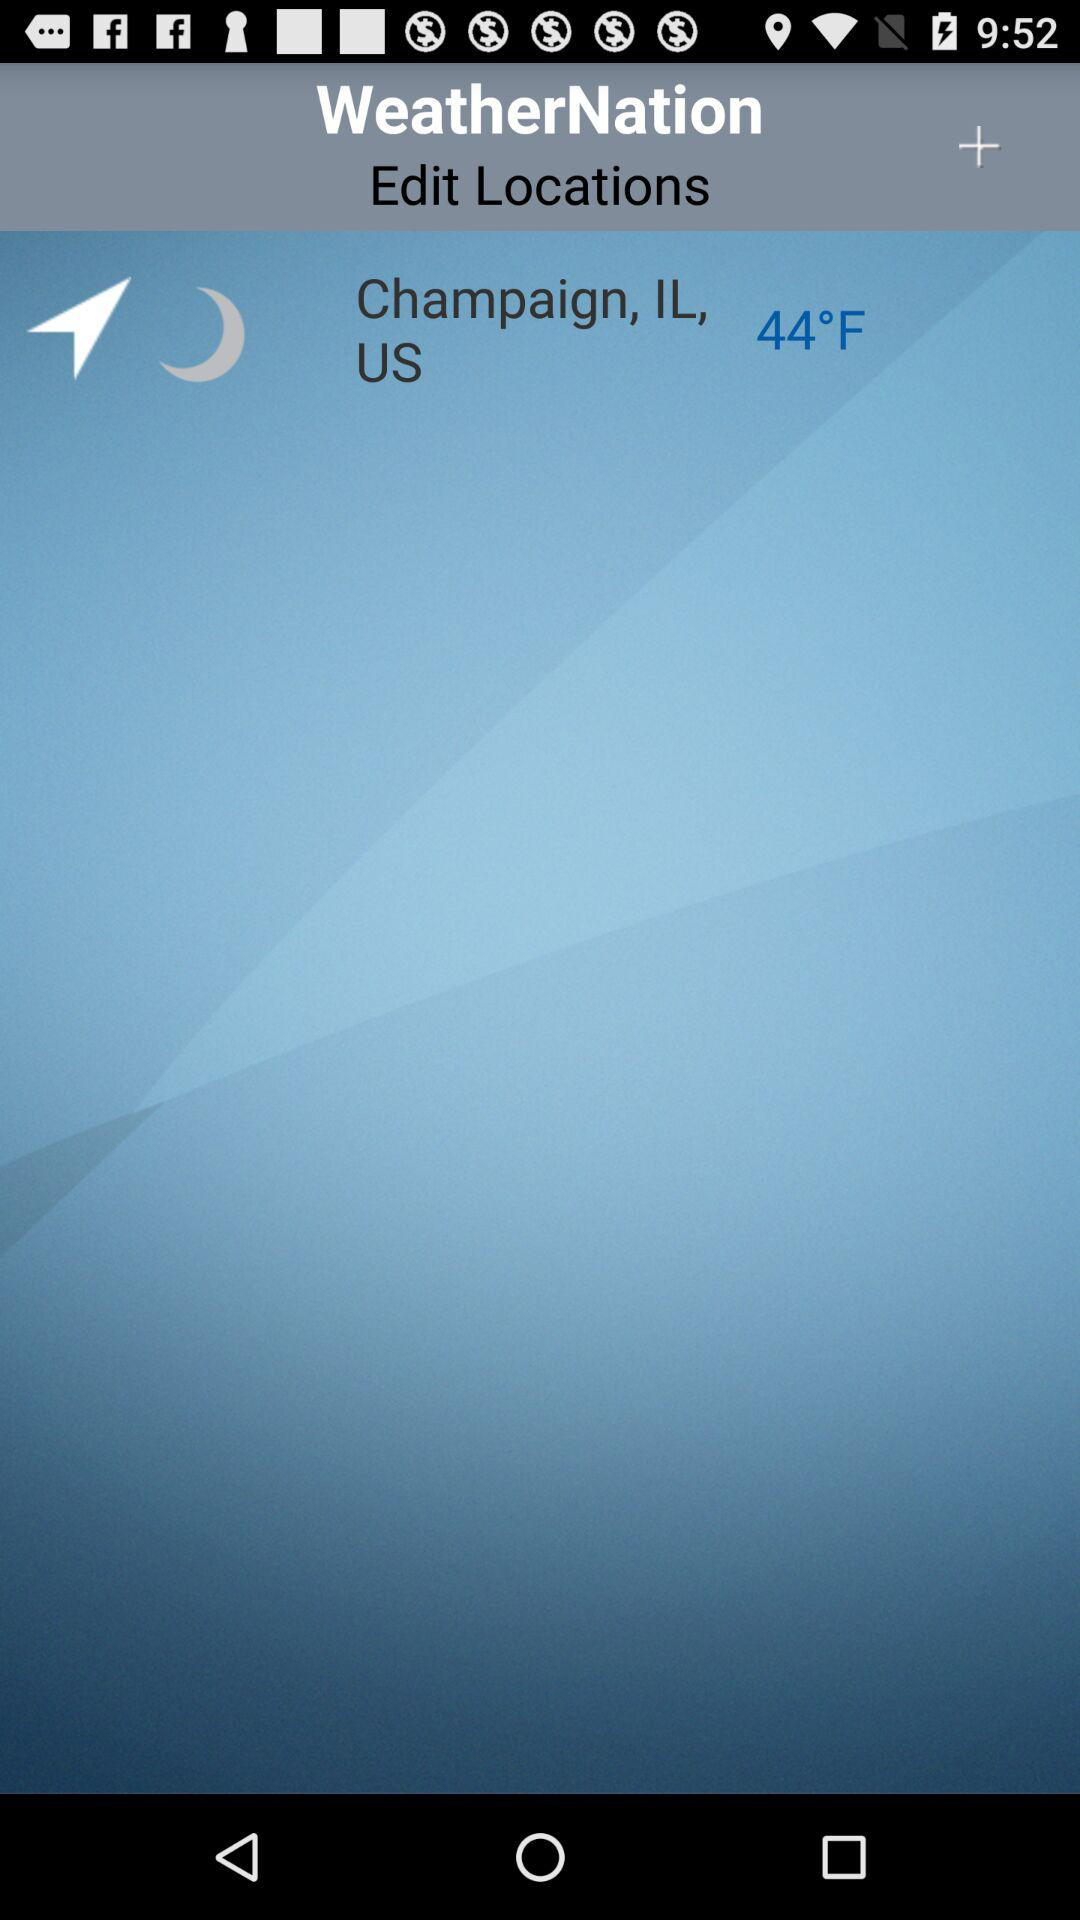What is the location? The location is Champaign, IL, US. 